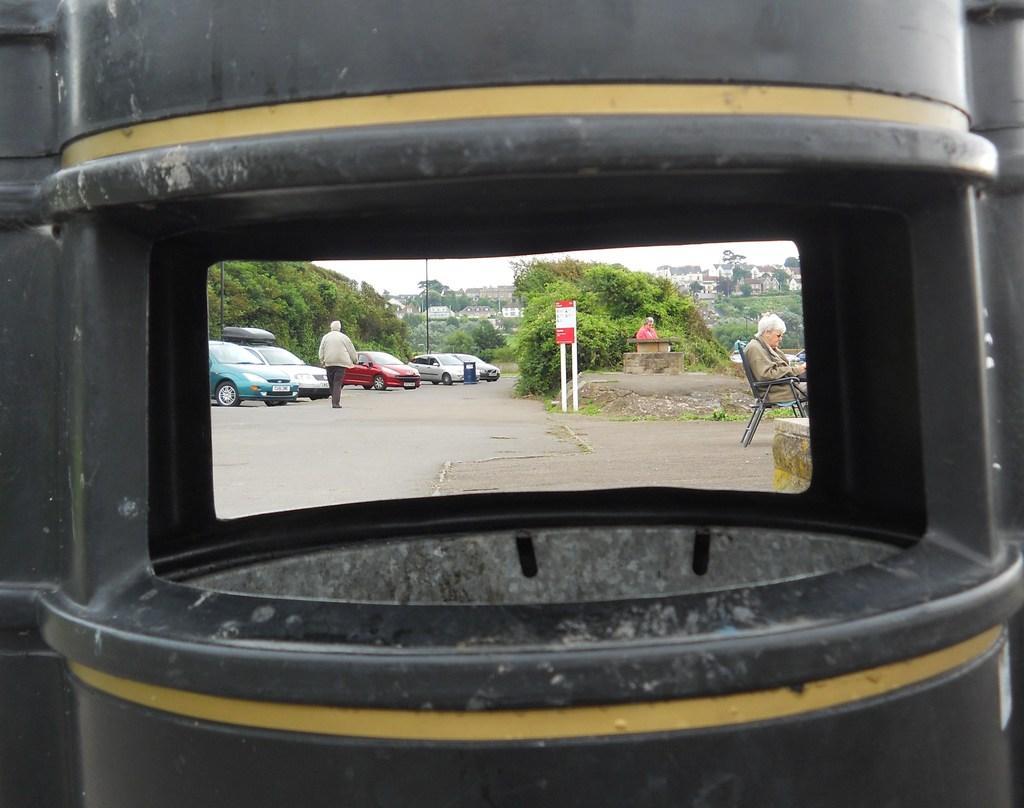Please provide a concise description of this image. In this image in front there is a black color object through which we can see cars. There is a board. There is a person walking on the road. There are buildings, trees. In the background of the image there is sky. On the right side of the image there is a person sitting on the chair. Behind the person there is another person. 